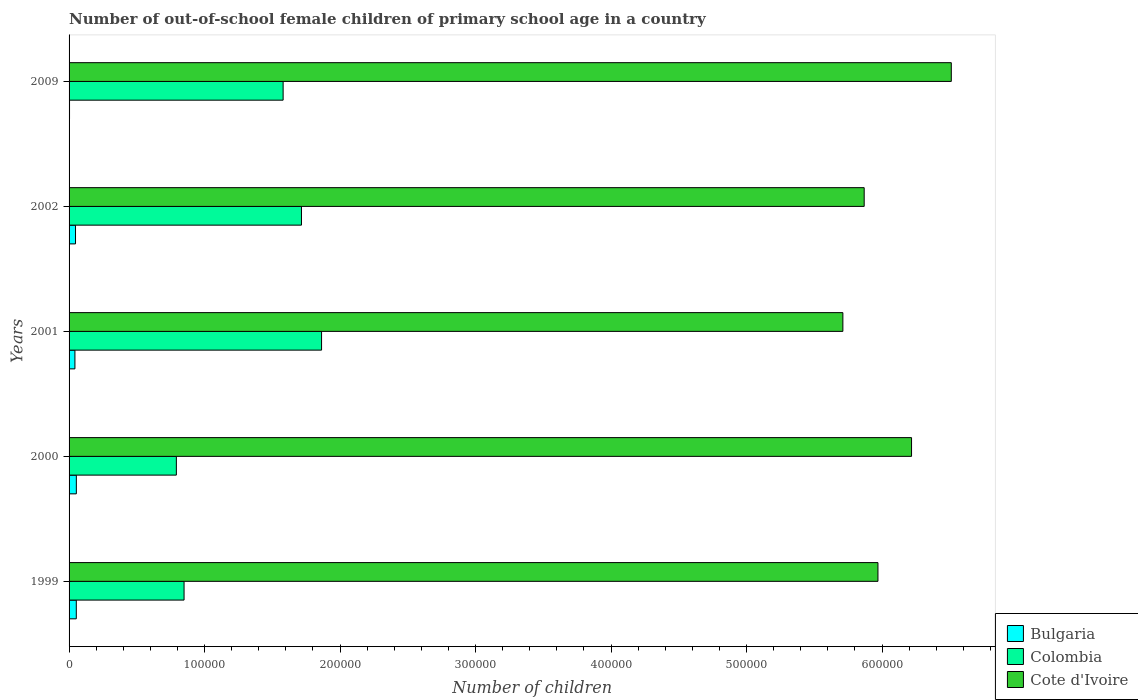How many different coloured bars are there?
Provide a short and direct response. 3. How many groups of bars are there?
Ensure brevity in your answer.  5. Are the number of bars per tick equal to the number of legend labels?
Provide a succinct answer. Yes. How many bars are there on the 3rd tick from the top?
Ensure brevity in your answer.  3. How many bars are there on the 1st tick from the bottom?
Provide a succinct answer. 3. In how many cases, is the number of bars for a given year not equal to the number of legend labels?
Your answer should be very brief. 0. What is the number of out-of-school female children in Bulgaria in 2001?
Offer a very short reply. 4313. Across all years, what is the maximum number of out-of-school female children in Bulgaria?
Ensure brevity in your answer.  5362. Across all years, what is the minimum number of out-of-school female children in Cote d'Ivoire?
Offer a terse response. 5.71e+05. In which year was the number of out-of-school female children in Cote d'Ivoire minimum?
Offer a terse response. 2001. What is the total number of out-of-school female children in Bulgaria in the graph?
Your answer should be very brief. 2.01e+04. What is the difference between the number of out-of-school female children in Cote d'Ivoire in 2001 and that in 2002?
Offer a terse response. -1.57e+04. What is the difference between the number of out-of-school female children in Bulgaria in 1999 and the number of out-of-school female children in Cote d'Ivoire in 2002?
Your answer should be compact. -5.81e+05. What is the average number of out-of-school female children in Bulgaria per year?
Your response must be concise. 4020. In the year 2002, what is the difference between the number of out-of-school female children in Cote d'Ivoire and number of out-of-school female children in Bulgaria?
Make the answer very short. 5.82e+05. What is the ratio of the number of out-of-school female children in Cote d'Ivoire in 2000 to that in 2001?
Offer a very short reply. 1.09. Is the number of out-of-school female children in Colombia in 1999 less than that in 2000?
Offer a terse response. No. What is the difference between the highest and the second highest number of out-of-school female children in Colombia?
Make the answer very short. 1.48e+04. What is the difference between the highest and the lowest number of out-of-school female children in Cote d'Ivoire?
Your answer should be compact. 8.00e+04. In how many years, is the number of out-of-school female children in Colombia greater than the average number of out-of-school female children in Colombia taken over all years?
Provide a short and direct response. 3. Is it the case that in every year, the sum of the number of out-of-school female children in Colombia and number of out-of-school female children in Cote d'Ivoire is greater than the number of out-of-school female children in Bulgaria?
Provide a succinct answer. Yes. How many bars are there?
Your answer should be very brief. 15. How many years are there in the graph?
Make the answer very short. 5. Are the values on the major ticks of X-axis written in scientific E-notation?
Your answer should be compact. No. How are the legend labels stacked?
Ensure brevity in your answer.  Vertical. What is the title of the graph?
Your answer should be very brief. Number of out-of-school female children of primary school age in a country. What is the label or title of the X-axis?
Ensure brevity in your answer.  Number of children. What is the Number of children of Bulgaria in 1999?
Offer a very short reply. 5332. What is the Number of children of Colombia in 1999?
Ensure brevity in your answer.  8.49e+04. What is the Number of children in Cote d'Ivoire in 1999?
Offer a terse response. 5.97e+05. What is the Number of children of Bulgaria in 2000?
Ensure brevity in your answer.  5362. What is the Number of children of Colombia in 2000?
Ensure brevity in your answer.  7.92e+04. What is the Number of children in Cote d'Ivoire in 2000?
Your answer should be very brief. 6.22e+05. What is the Number of children of Bulgaria in 2001?
Ensure brevity in your answer.  4313. What is the Number of children in Colombia in 2001?
Offer a terse response. 1.86e+05. What is the Number of children of Cote d'Ivoire in 2001?
Offer a very short reply. 5.71e+05. What is the Number of children in Bulgaria in 2002?
Your response must be concise. 4759. What is the Number of children in Colombia in 2002?
Your answer should be very brief. 1.72e+05. What is the Number of children in Cote d'Ivoire in 2002?
Your response must be concise. 5.87e+05. What is the Number of children in Bulgaria in 2009?
Keep it short and to the point. 334. What is the Number of children of Colombia in 2009?
Offer a very short reply. 1.58e+05. What is the Number of children in Cote d'Ivoire in 2009?
Your answer should be compact. 6.51e+05. Across all years, what is the maximum Number of children of Bulgaria?
Give a very brief answer. 5362. Across all years, what is the maximum Number of children in Colombia?
Keep it short and to the point. 1.86e+05. Across all years, what is the maximum Number of children of Cote d'Ivoire?
Provide a succinct answer. 6.51e+05. Across all years, what is the minimum Number of children of Bulgaria?
Ensure brevity in your answer.  334. Across all years, what is the minimum Number of children of Colombia?
Your answer should be compact. 7.92e+04. Across all years, what is the minimum Number of children of Cote d'Ivoire?
Offer a terse response. 5.71e+05. What is the total Number of children of Bulgaria in the graph?
Ensure brevity in your answer.  2.01e+04. What is the total Number of children in Colombia in the graph?
Make the answer very short. 6.80e+05. What is the total Number of children in Cote d'Ivoire in the graph?
Offer a terse response. 3.03e+06. What is the difference between the Number of children in Bulgaria in 1999 and that in 2000?
Your answer should be very brief. -30. What is the difference between the Number of children in Colombia in 1999 and that in 2000?
Your response must be concise. 5677. What is the difference between the Number of children of Cote d'Ivoire in 1999 and that in 2000?
Give a very brief answer. -2.48e+04. What is the difference between the Number of children in Bulgaria in 1999 and that in 2001?
Give a very brief answer. 1019. What is the difference between the Number of children in Colombia in 1999 and that in 2001?
Your response must be concise. -1.01e+05. What is the difference between the Number of children in Cote d'Ivoire in 1999 and that in 2001?
Your response must be concise. 2.59e+04. What is the difference between the Number of children of Bulgaria in 1999 and that in 2002?
Provide a succinct answer. 573. What is the difference between the Number of children of Colombia in 1999 and that in 2002?
Give a very brief answer. -8.66e+04. What is the difference between the Number of children in Cote d'Ivoire in 1999 and that in 2002?
Provide a succinct answer. 1.02e+04. What is the difference between the Number of children in Bulgaria in 1999 and that in 2009?
Offer a very short reply. 4998. What is the difference between the Number of children in Colombia in 1999 and that in 2009?
Your answer should be very brief. -7.31e+04. What is the difference between the Number of children in Cote d'Ivoire in 1999 and that in 2009?
Your answer should be very brief. -5.41e+04. What is the difference between the Number of children of Bulgaria in 2000 and that in 2001?
Provide a short and direct response. 1049. What is the difference between the Number of children in Colombia in 2000 and that in 2001?
Provide a short and direct response. -1.07e+05. What is the difference between the Number of children in Cote d'Ivoire in 2000 and that in 2001?
Make the answer very short. 5.07e+04. What is the difference between the Number of children of Bulgaria in 2000 and that in 2002?
Give a very brief answer. 603. What is the difference between the Number of children of Colombia in 2000 and that in 2002?
Give a very brief answer. -9.23e+04. What is the difference between the Number of children of Cote d'Ivoire in 2000 and that in 2002?
Offer a terse response. 3.50e+04. What is the difference between the Number of children of Bulgaria in 2000 and that in 2009?
Make the answer very short. 5028. What is the difference between the Number of children in Colombia in 2000 and that in 2009?
Provide a succinct answer. -7.88e+04. What is the difference between the Number of children in Cote d'Ivoire in 2000 and that in 2009?
Provide a succinct answer. -2.93e+04. What is the difference between the Number of children in Bulgaria in 2001 and that in 2002?
Give a very brief answer. -446. What is the difference between the Number of children in Colombia in 2001 and that in 2002?
Offer a terse response. 1.48e+04. What is the difference between the Number of children of Cote d'Ivoire in 2001 and that in 2002?
Provide a succinct answer. -1.57e+04. What is the difference between the Number of children in Bulgaria in 2001 and that in 2009?
Give a very brief answer. 3979. What is the difference between the Number of children of Colombia in 2001 and that in 2009?
Provide a short and direct response. 2.84e+04. What is the difference between the Number of children of Cote d'Ivoire in 2001 and that in 2009?
Offer a very short reply. -8.00e+04. What is the difference between the Number of children in Bulgaria in 2002 and that in 2009?
Your answer should be very brief. 4425. What is the difference between the Number of children of Colombia in 2002 and that in 2009?
Your answer should be very brief. 1.35e+04. What is the difference between the Number of children of Cote d'Ivoire in 2002 and that in 2009?
Your answer should be compact. -6.43e+04. What is the difference between the Number of children in Bulgaria in 1999 and the Number of children in Colombia in 2000?
Your answer should be compact. -7.39e+04. What is the difference between the Number of children in Bulgaria in 1999 and the Number of children in Cote d'Ivoire in 2000?
Ensure brevity in your answer.  -6.16e+05. What is the difference between the Number of children of Colombia in 1999 and the Number of children of Cote d'Ivoire in 2000?
Your answer should be very brief. -5.37e+05. What is the difference between the Number of children in Bulgaria in 1999 and the Number of children in Colombia in 2001?
Offer a very short reply. -1.81e+05. What is the difference between the Number of children in Bulgaria in 1999 and the Number of children in Cote d'Ivoire in 2001?
Make the answer very short. -5.66e+05. What is the difference between the Number of children in Colombia in 1999 and the Number of children in Cote d'Ivoire in 2001?
Offer a very short reply. -4.86e+05. What is the difference between the Number of children of Bulgaria in 1999 and the Number of children of Colombia in 2002?
Your answer should be very brief. -1.66e+05. What is the difference between the Number of children in Bulgaria in 1999 and the Number of children in Cote d'Ivoire in 2002?
Your answer should be very brief. -5.81e+05. What is the difference between the Number of children of Colombia in 1999 and the Number of children of Cote d'Ivoire in 2002?
Make the answer very short. -5.02e+05. What is the difference between the Number of children in Bulgaria in 1999 and the Number of children in Colombia in 2009?
Provide a short and direct response. -1.53e+05. What is the difference between the Number of children of Bulgaria in 1999 and the Number of children of Cote d'Ivoire in 2009?
Your answer should be very brief. -6.46e+05. What is the difference between the Number of children of Colombia in 1999 and the Number of children of Cote d'Ivoire in 2009?
Offer a very short reply. -5.66e+05. What is the difference between the Number of children in Bulgaria in 2000 and the Number of children in Colombia in 2001?
Keep it short and to the point. -1.81e+05. What is the difference between the Number of children in Bulgaria in 2000 and the Number of children in Cote d'Ivoire in 2001?
Your answer should be compact. -5.66e+05. What is the difference between the Number of children of Colombia in 2000 and the Number of children of Cote d'Ivoire in 2001?
Ensure brevity in your answer.  -4.92e+05. What is the difference between the Number of children of Bulgaria in 2000 and the Number of children of Colombia in 2002?
Make the answer very short. -1.66e+05. What is the difference between the Number of children in Bulgaria in 2000 and the Number of children in Cote d'Ivoire in 2002?
Give a very brief answer. -5.81e+05. What is the difference between the Number of children of Colombia in 2000 and the Number of children of Cote d'Ivoire in 2002?
Make the answer very short. -5.08e+05. What is the difference between the Number of children in Bulgaria in 2000 and the Number of children in Colombia in 2009?
Offer a very short reply. -1.53e+05. What is the difference between the Number of children in Bulgaria in 2000 and the Number of children in Cote d'Ivoire in 2009?
Provide a short and direct response. -6.46e+05. What is the difference between the Number of children in Colombia in 2000 and the Number of children in Cote d'Ivoire in 2009?
Your response must be concise. -5.72e+05. What is the difference between the Number of children of Bulgaria in 2001 and the Number of children of Colombia in 2002?
Offer a very short reply. -1.67e+05. What is the difference between the Number of children of Bulgaria in 2001 and the Number of children of Cote d'Ivoire in 2002?
Your answer should be very brief. -5.82e+05. What is the difference between the Number of children in Colombia in 2001 and the Number of children in Cote d'Ivoire in 2002?
Offer a terse response. -4.00e+05. What is the difference between the Number of children in Bulgaria in 2001 and the Number of children in Colombia in 2009?
Ensure brevity in your answer.  -1.54e+05. What is the difference between the Number of children in Bulgaria in 2001 and the Number of children in Cote d'Ivoire in 2009?
Your answer should be compact. -6.47e+05. What is the difference between the Number of children in Colombia in 2001 and the Number of children in Cote d'Ivoire in 2009?
Your response must be concise. -4.65e+05. What is the difference between the Number of children in Bulgaria in 2002 and the Number of children in Colombia in 2009?
Your answer should be compact. -1.53e+05. What is the difference between the Number of children in Bulgaria in 2002 and the Number of children in Cote d'Ivoire in 2009?
Your response must be concise. -6.46e+05. What is the difference between the Number of children of Colombia in 2002 and the Number of children of Cote d'Ivoire in 2009?
Your answer should be very brief. -4.80e+05. What is the average Number of children of Bulgaria per year?
Make the answer very short. 4020. What is the average Number of children of Colombia per year?
Provide a succinct answer. 1.36e+05. What is the average Number of children of Cote d'Ivoire per year?
Your answer should be very brief. 6.06e+05. In the year 1999, what is the difference between the Number of children of Bulgaria and Number of children of Colombia?
Your response must be concise. -7.95e+04. In the year 1999, what is the difference between the Number of children in Bulgaria and Number of children in Cote d'Ivoire?
Provide a succinct answer. -5.92e+05. In the year 1999, what is the difference between the Number of children of Colombia and Number of children of Cote d'Ivoire?
Give a very brief answer. -5.12e+05. In the year 2000, what is the difference between the Number of children in Bulgaria and Number of children in Colombia?
Provide a succinct answer. -7.38e+04. In the year 2000, what is the difference between the Number of children of Bulgaria and Number of children of Cote d'Ivoire?
Give a very brief answer. -6.16e+05. In the year 2000, what is the difference between the Number of children of Colombia and Number of children of Cote d'Ivoire?
Offer a terse response. -5.43e+05. In the year 2001, what is the difference between the Number of children of Bulgaria and Number of children of Colombia?
Offer a very short reply. -1.82e+05. In the year 2001, what is the difference between the Number of children in Bulgaria and Number of children in Cote d'Ivoire?
Provide a short and direct response. -5.67e+05. In the year 2001, what is the difference between the Number of children of Colombia and Number of children of Cote d'Ivoire?
Make the answer very short. -3.85e+05. In the year 2002, what is the difference between the Number of children of Bulgaria and Number of children of Colombia?
Provide a short and direct response. -1.67e+05. In the year 2002, what is the difference between the Number of children of Bulgaria and Number of children of Cote d'Ivoire?
Give a very brief answer. -5.82e+05. In the year 2002, what is the difference between the Number of children in Colombia and Number of children in Cote d'Ivoire?
Make the answer very short. -4.15e+05. In the year 2009, what is the difference between the Number of children of Bulgaria and Number of children of Colombia?
Make the answer very short. -1.58e+05. In the year 2009, what is the difference between the Number of children of Bulgaria and Number of children of Cote d'Ivoire?
Keep it short and to the point. -6.51e+05. In the year 2009, what is the difference between the Number of children in Colombia and Number of children in Cote d'Ivoire?
Keep it short and to the point. -4.93e+05. What is the ratio of the Number of children of Colombia in 1999 to that in 2000?
Offer a very short reply. 1.07. What is the ratio of the Number of children in Cote d'Ivoire in 1999 to that in 2000?
Give a very brief answer. 0.96. What is the ratio of the Number of children in Bulgaria in 1999 to that in 2001?
Ensure brevity in your answer.  1.24. What is the ratio of the Number of children of Colombia in 1999 to that in 2001?
Ensure brevity in your answer.  0.46. What is the ratio of the Number of children of Cote d'Ivoire in 1999 to that in 2001?
Offer a very short reply. 1.05. What is the ratio of the Number of children in Bulgaria in 1999 to that in 2002?
Offer a terse response. 1.12. What is the ratio of the Number of children of Colombia in 1999 to that in 2002?
Ensure brevity in your answer.  0.49. What is the ratio of the Number of children in Cote d'Ivoire in 1999 to that in 2002?
Give a very brief answer. 1.02. What is the ratio of the Number of children of Bulgaria in 1999 to that in 2009?
Ensure brevity in your answer.  15.96. What is the ratio of the Number of children of Colombia in 1999 to that in 2009?
Offer a very short reply. 0.54. What is the ratio of the Number of children of Cote d'Ivoire in 1999 to that in 2009?
Make the answer very short. 0.92. What is the ratio of the Number of children of Bulgaria in 2000 to that in 2001?
Make the answer very short. 1.24. What is the ratio of the Number of children in Colombia in 2000 to that in 2001?
Offer a very short reply. 0.42. What is the ratio of the Number of children in Cote d'Ivoire in 2000 to that in 2001?
Offer a very short reply. 1.09. What is the ratio of the Number of children in Bulgaria in 2000 to that in 2002?
Your answer should be very brief. 1.13. What is the ratio of the Number of children of Colombia in 2000 to that in 2002?
Your response must be concise. 0.46. What is the ratio of the Number of children in Cote d'Ivoire in 2000 to that in 2002?
Your response must be concise. 1.06. What is the ratio of the Number of children of Bulgaria in 2000 to that in 2009?
Make the answer very short. 16.05. What is the ratio of the Number of children in Colombia in 2000 to that in 2009?
Your answer should be compact. 0.5. What is the ratio of the Number of children of Cote d'Ivoire in 2000 to that in 2009?
Your answer should be compact. 0.95. What is the ratio of the Number of children in Bulgaria in 2001 to that in 2002?
Ensure brevity in your answer.  0.91. What is the ratio of the Number of children of Colombia in 2001 to that in 2002?
Make the answer very short. 1.09. What is the ratio of the Number of children of Cote d'Ivoire in 2001 to that in 2002?
Your response must be concise. 0.97. What is the ratio of the Number of children of Bulgaria in 2001 to that in 2009?
Provide a succinct answer. 12.91. What is the ratio of the Number of children of Colombia in 2001 to that in 2009?
Keep it short and to the point. 1.18. What is the ratio of the Number of children in Cote d'Ivoire in 2001 to that in 2009?
Your answer should be very brief. 0.88. What is the ratio of the Number of children of Bulgaria in 2002 to that in 2009?
Offer a terse response. 14.25. What is the ratio of the Number of children of Colombia in 2002 to that in 2009?
Make the answer very short. 1.09. What is the ratio of the Number of children of Cote d'Ivoire in 2002 to that in 2009?
Keep it short and to the point. 0.9. What is the difference between the highest and the second highest Number of children of Bulgaria?
Offer a very short reply. 30. What is the difference between the highest and the second highest Number of children in Colombia?
Give a very brief answer. 1.48e+04. What is the difference between the highest and the second highest Number of children of Cote d'Ivoire?
Your answer should be very brief. 2.93e+04. What is the difference between the highest and the lowest Number of children in Bulgaria?
Your response must be concise. 5028. What is the difference between the highest and the lowest Number of children of Colombia?
Provide a short and direct response. 1.07e+05. What is the difference between the highest and the lowest Number of children in Cote d'Ivoire?
Give a very brief answer. 8.00e+04. 